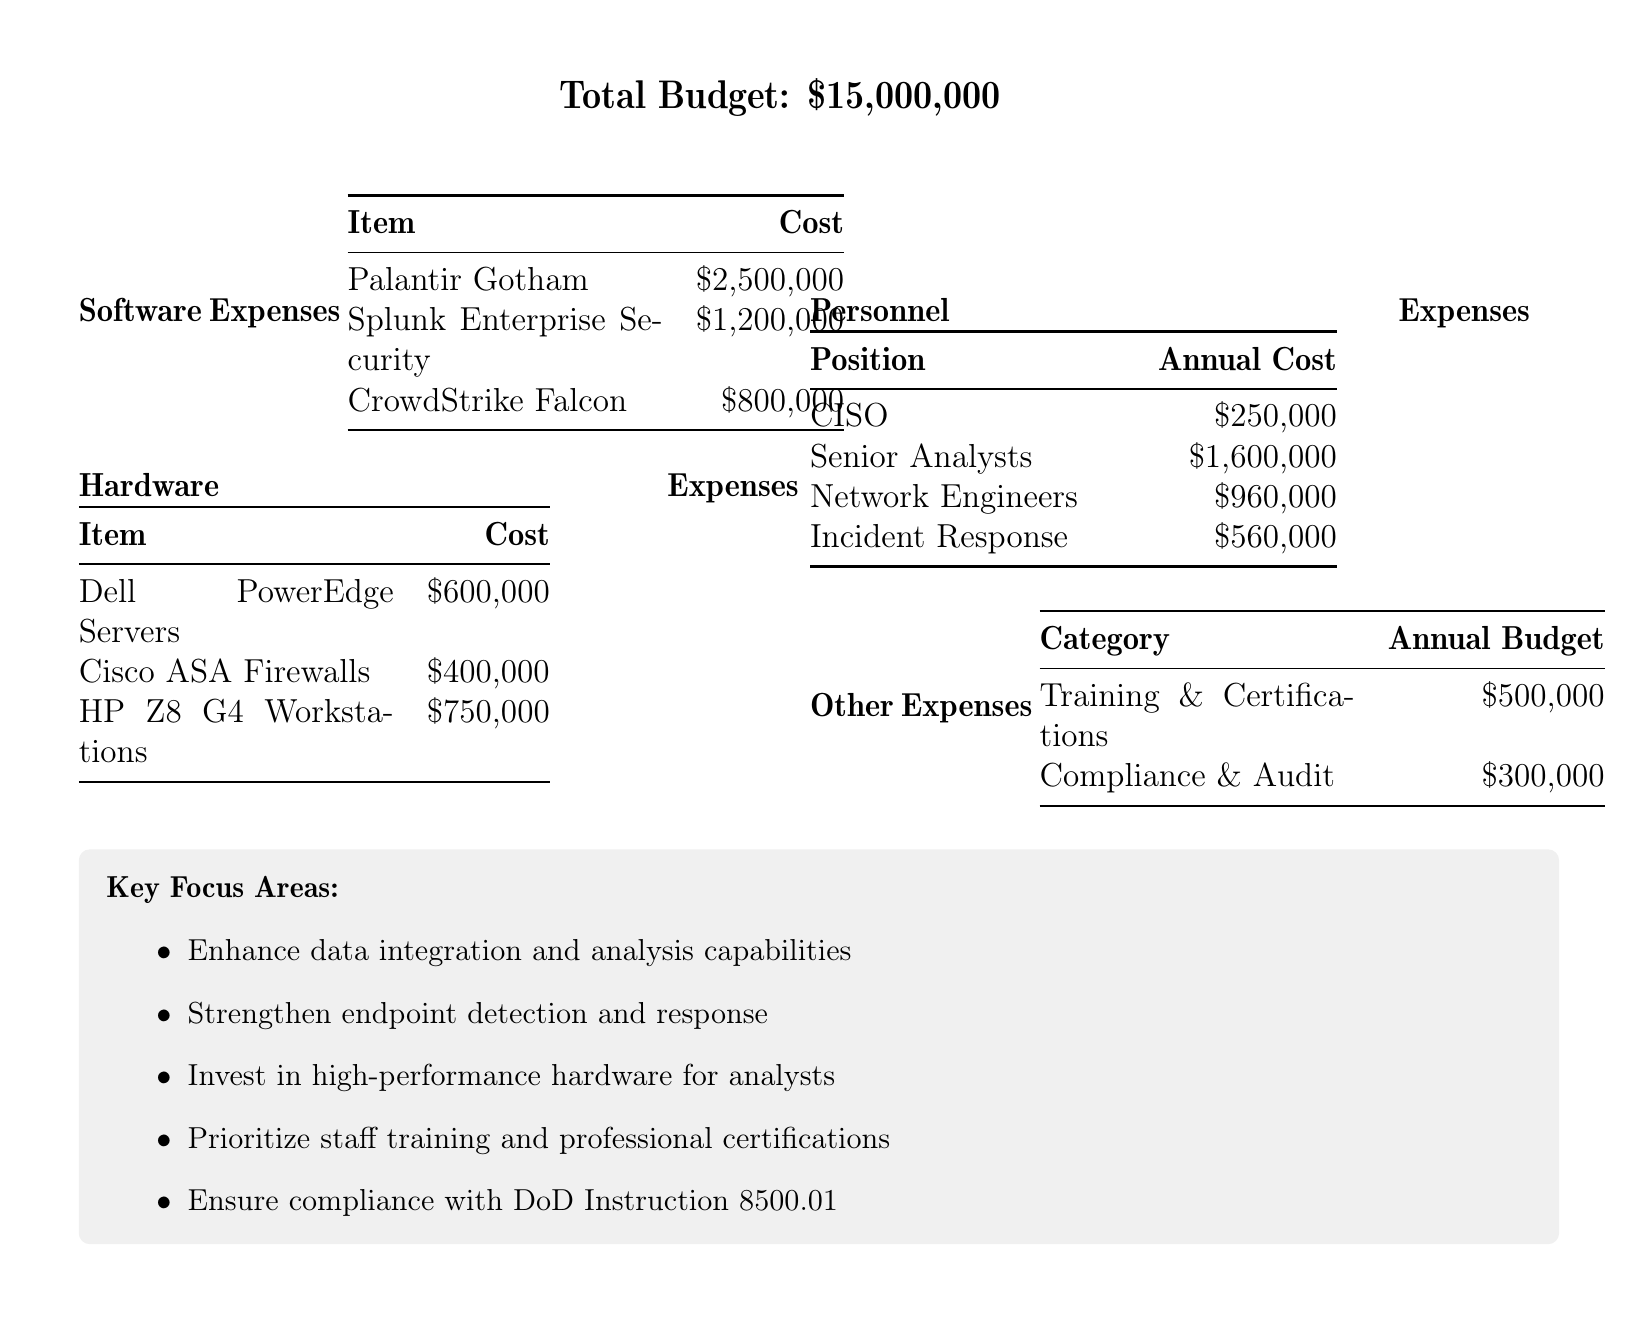What is the total budget? The total budget is explicitly stated in the document.
Answer: $15,000,000 How much does Palantir Gotham cost? The cost of Palantir Gotham is listed under Software Expenses.
Answer: $2,500,000 What is the cost of Cisco ASA Firewalls? The cost of Cisco ASA Firewalls is found in the Hardware Expenses section.
Answer: $400,000 What is the annual cost for Senior Analysts? The annual cost for Senior Analysts is specified in the Personnel Expenses table.
Answer: $1,600,000 How much is allocated for Training & Certifications? The allocation for Training & Certifications is detailed under Other Expenses.
Answer: $500,000 What is the combined cost of software expenses? The combined cost of software expenses requires adding all individual software costs listed.
Answer: $4,500,000 How many categories are listed under Other Expenses? The document provides a summary of categories under Other Expenses.
Answer: 2 What are the key focus areas listed in the document? The document outlines specific focus areas as part of the budget strategy.
Answer: Enhance data integration and analysis capabilities, Strengthen endpoint detection and response, Invest in high-performance hardware for analysts, Prioritize staff training and professional certifications, Ensure compliance with DoD Instruction 8500.01 Which personnel position has the highest cost? The highest cost position can be found by comparing annual costs in the Personnel Expenses section.
Answer: Senior Analysts 